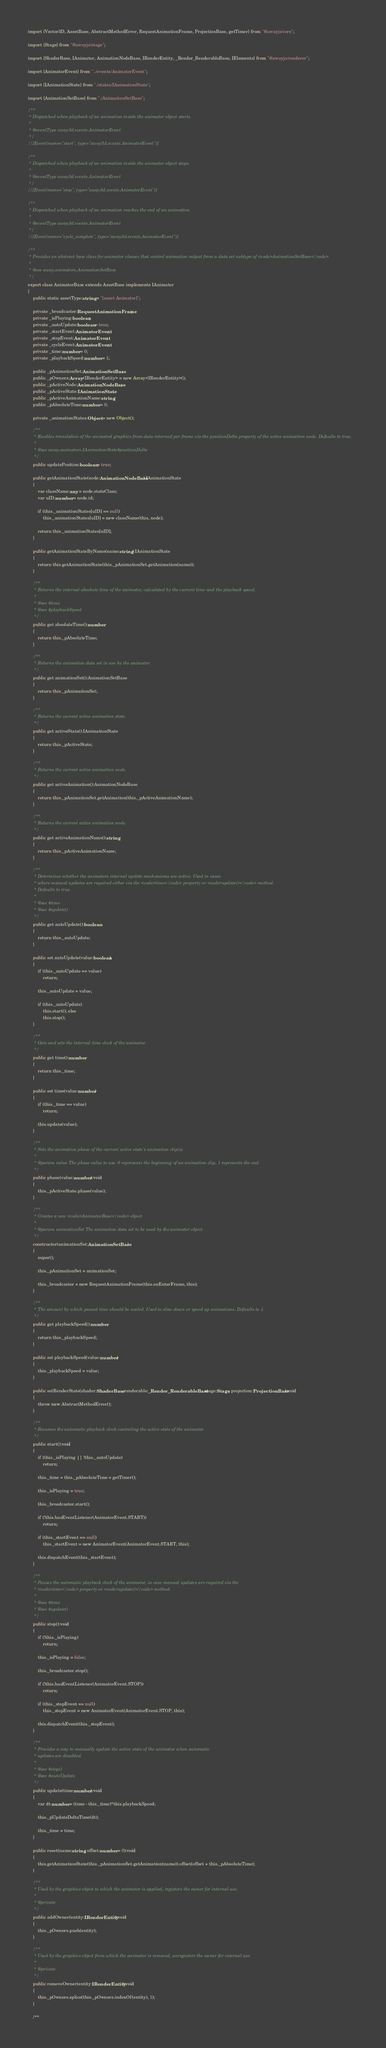Convert code to text. <code><loc_0><loc_0><loc_500><loc_500><_TypeScript_>import {Vector3D, AssetBase, AbstractMethodError, RequestAnimationFrame, ProjectionBase, getTimer} from "@awayjs/core";

import {Stage} from "@awayjs/stage";

import {ShaderBase, IAnimator, AnimationNodeBase, IRenderEntity, _Render_RenderableBase, IElements} from "@awayjs/renderer";

import {AnimatorEvent} from "../events/AnimatorEvent";

import {IAnimationState} from "./states/IAnimationState";

import {AnimationSetBase} from "./AnimationSetBase";

/**
 * Dispatched when playback of an animation inside the animator object starts.
 *
 * @eventType away3d.events.AnimatorEvent
 */
//[Event(name="start", type="away3d.events.AnimatorEvent")]

/**
 * Dispatched when playback of an animation inside the animator object stops.
 *
 * @eventType away3d.events.AnimatorEvent
 */
//[Event(name="stop", type="away3d.events.AnimatorEvent")]

/**
 * Dispatched when playback of an animation reaches the end of an animation.
 *
 * @eventType away3d.events.AnimatorEvent
 */
//[Event(name="cycle_complete", type="away3d.events.AnimatorEvent")]

/**
 * Provides an abstract base class for animator classes that control animation output from a data set subtype of <code>AnimationSetBase</code>.
 *
 * @see away.animators.AnimationSetBase
 */
export class AnimatorBase extends AssetBase implements IAnimator
{
	public static assetType:string = "[asset Animator]";

	private _broadcaster:RequestAnimationFrame;
	private _isPlaying:boolean;
	private _autoUpdate:boolean = true;
	private _startEvent:AnimatorEvent;
	private _stopEvent:AnimatorEvent;
	private _cycleEvent:AnimatorEvent;
	private _time:number = 0;
	private _playbackSpeed:number = 1;

	public _pAnimationSet:AnimationSetBase;
	public _pOwners:Array<IRenderEntity> = new Array<IRenderEntity>();
	public _pActiveNode:AnimationNodeBase;
	public _pActiveState:IAnimationState;
	public _pActiveAnimationName:string;
	public _pAbsoluteTime:number = 0;

	private _animationStates:Object = new Object();

	/**
	 * Enables translation of the animated graphics from data returned per frame via the positionDelta property of the active animation node. Defaults to true.
	 *
	 * @see away.animators.IAnimationState#positionDelta
	 */
	public updatePosition:boolean = true;

	public getAnimationState(node:AnimationNodeBase):IAnimationState
	{
		var className:any = node.stateClass;
		var uID:number = node.id;

		if (this._animationStates[uID] == null)
			this._animationStates[uID] = new className(this, node);

		return this._animationStates[uID];
	}

	public getAnimationStateByName(name:string):IAnimationState
	{
		return this.getAnimationState(this._pAnimationSet.getAnimation(name));
	}

	/**
	 * Returns the internal absolute time of the animator, calculated by the current time and the playback speed.
	 *
	 * @see #time
	 * @see #playbackSpeed
	 */
	public get absoluteTime():number
	{
		return this._pAbsoluteTime;
	}

	/**
	 * Returns the animation data set in use by the animator.
	 */
	public get animationSet():AnimationSetBase
	{
		return this._pAnimationSet;
	}

	/**
	 * Returns the current active animation state.
	 */
	public get activeState():IAnimationState
	{
		return this._pActiveState;
	}

	/**
	 * Returns the current active animation node.
	 */
	public get activeAnimation():AnimationNodeBase
	{
		return this._pAnimationSet.getAnimation(this._pActiveAnimationName);
	}

	/**
	 * Returns the current active animation node.
	 */
	public get activeAnimationName():string
	{
		return this._pActiveAnimationName;
	}

	/**
	 * Determines whether the animators internal update mechanisms are active. Used in cases
	 * where manual updates are required either via the <code>time</code> property or <code>update()</code> method.
	 * Defaults to true.
	 *
	 * @see #time
	 * @see #update()
	 */
	public get autoUpdate():boolean
	{
		return this._autoUpdate;
	}

	public set autoUpdate(value:boolean)
	{
		if (this._autoUpdate == value)
			return;

		this._autoUpdate = value;

		if (this._autoUpdate)
			this.start(); else
			this.stop();
	}

	/**
	 * Gets and sets the internal time clock of the animator.
	 */
	public get time():number
	{
		return this._time;
	}

	public set time(value:number)
	{
		if (this._time == value)
			return;

		this.update(value);
	}

	/**
	 * Sets the animation phase of the current active state's animation clip(s).
	 *
	 * @param value The phase value to use. 0 represents the beginning of an animation clip, 1 represents the end.
	 */
	public phase(value:number):void
	{
		this._pActiveState.phase(value);
	}

	/**
	 * Creates a new <code>AnimatorBase</code> object.
	 *
	 * @param animationSet The animation data set to be used by the animator object.
	 */
	constructor(animationSet:AnimationSetBase)
	{
		super();

		this._pAnimationSet = animationSet;

		this._broadcaster = new RequestAnimationFrame(this.onEnterFrame, this);
	}

	/**
	 * The amount by which passed time should be scaled. Used to slow down or speed up animations. Defaults to 1.
	 */
	public get playbackSpeed():number
	{
		return this._playbackSpeed;
	}

	public set playbackSpeed(value:number)
	{
		this._playbackSpeed = value;
	}

	public setRenderState(shader:ShaderBase, renderable:_Render_RenderableBase, stage:Stage, projection:ProjectionBase):void
	{
		throw new AbstractMethodError();
	}

	/**
	 * Resumes the automatic playback clock controling the active state of the animator.
	 */
	public start():void
	{
		if (this._isPlaying || !this._autoUpdate)
			return;

		this._time = this._pAbsoluteTime = getTimer();

		this._isPlaying = true;

		this._broadcaster.start();

		if (!this.hasEventListener(AnimatorEvent.START))
			return;

		if (this._startEvent == null)
			this._startEvent = new AnimatorEvent(AnimatorEvent.START, this);

		this.dispatchEvent(this._startEvent);
	}

	/**
	 * Pauses the automatic playback clock of the animator, in case manual updates are required via the
	 * <code>time</code> property or <code>update()</code> method.
	 *
	 * @see #time
	 * @see #update()
	 */
	public stop():void
	{
		if (!this._isPlaying)
			return;

		this._isPlaying = false;

		this._broadcaster.stop();

		if (!this.hasEventListener(AnimatorEvent.STOP))
			return;

		if (this._stopEvent == null)
			this._stopEvent = new AnimatorEvent(AnimatorEvent.STOP, this);

		this.dispatchEvent(this._stopEvent);
	}

	/**
	 * Provides a way to manually update the active state of the animator when automatic
	 * updates are disabled.
	 *
	 * @see #stop()
	 * @see #autoUpdate
	 */
	public update(time:number):void
	{
		var dt:number = (time - this._time)*this.playbackSpeed;

		this._pUpdateDeltaTime(dt);

		this._time = time;
	}

	public reset(name:string, offset:number = 0):void
	{
		this.getAnimationState(this._pAnimationSet.getAnimation(name)).offset(offset + this._pAbsoluteTime);
	}

	/**
	 * Used by the graphics object to which the animator is applied, registers the owner for internal use.
	 *
	 * @private
	 */
	public addOwner(entity:IRenderEntity):void
	{
		this._pOwners.push(entity);
	}

	/**
	 * Used by the graphics object from which the animator is removed, unregisters the owner for internal use.
	 *
	 * @private
	 */
	public removeOwner(entity:IRenderEntity):void
	{
		this._pOwners.splice(this._pOwners.indexOf(entity), 1);
	}

	/**</code> 